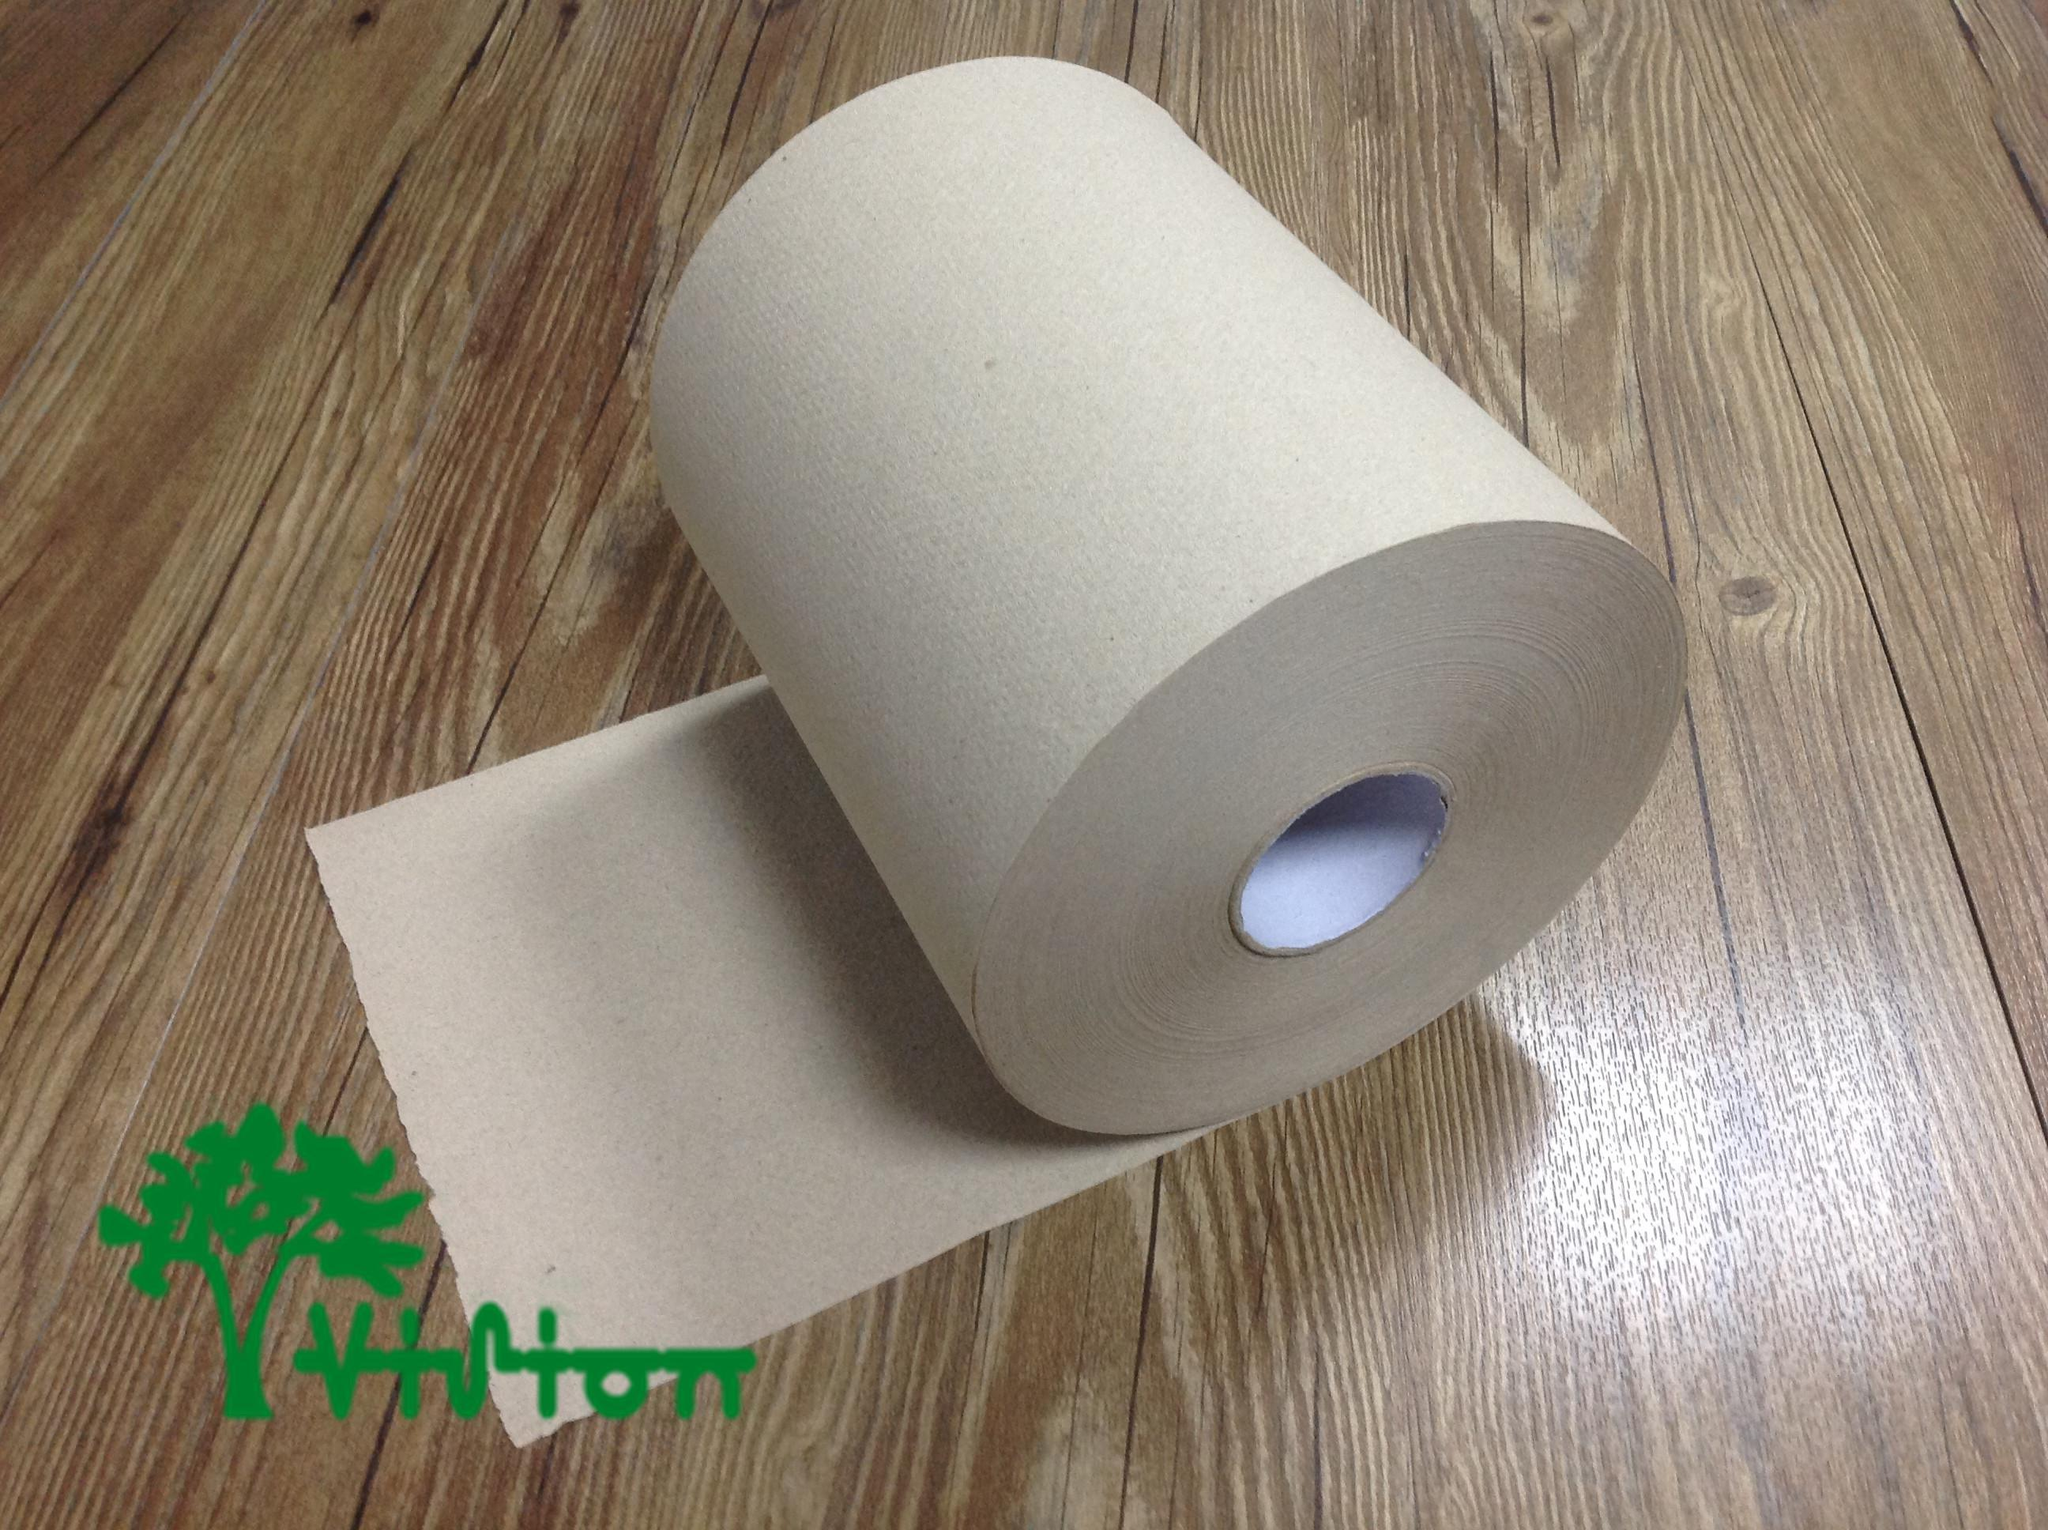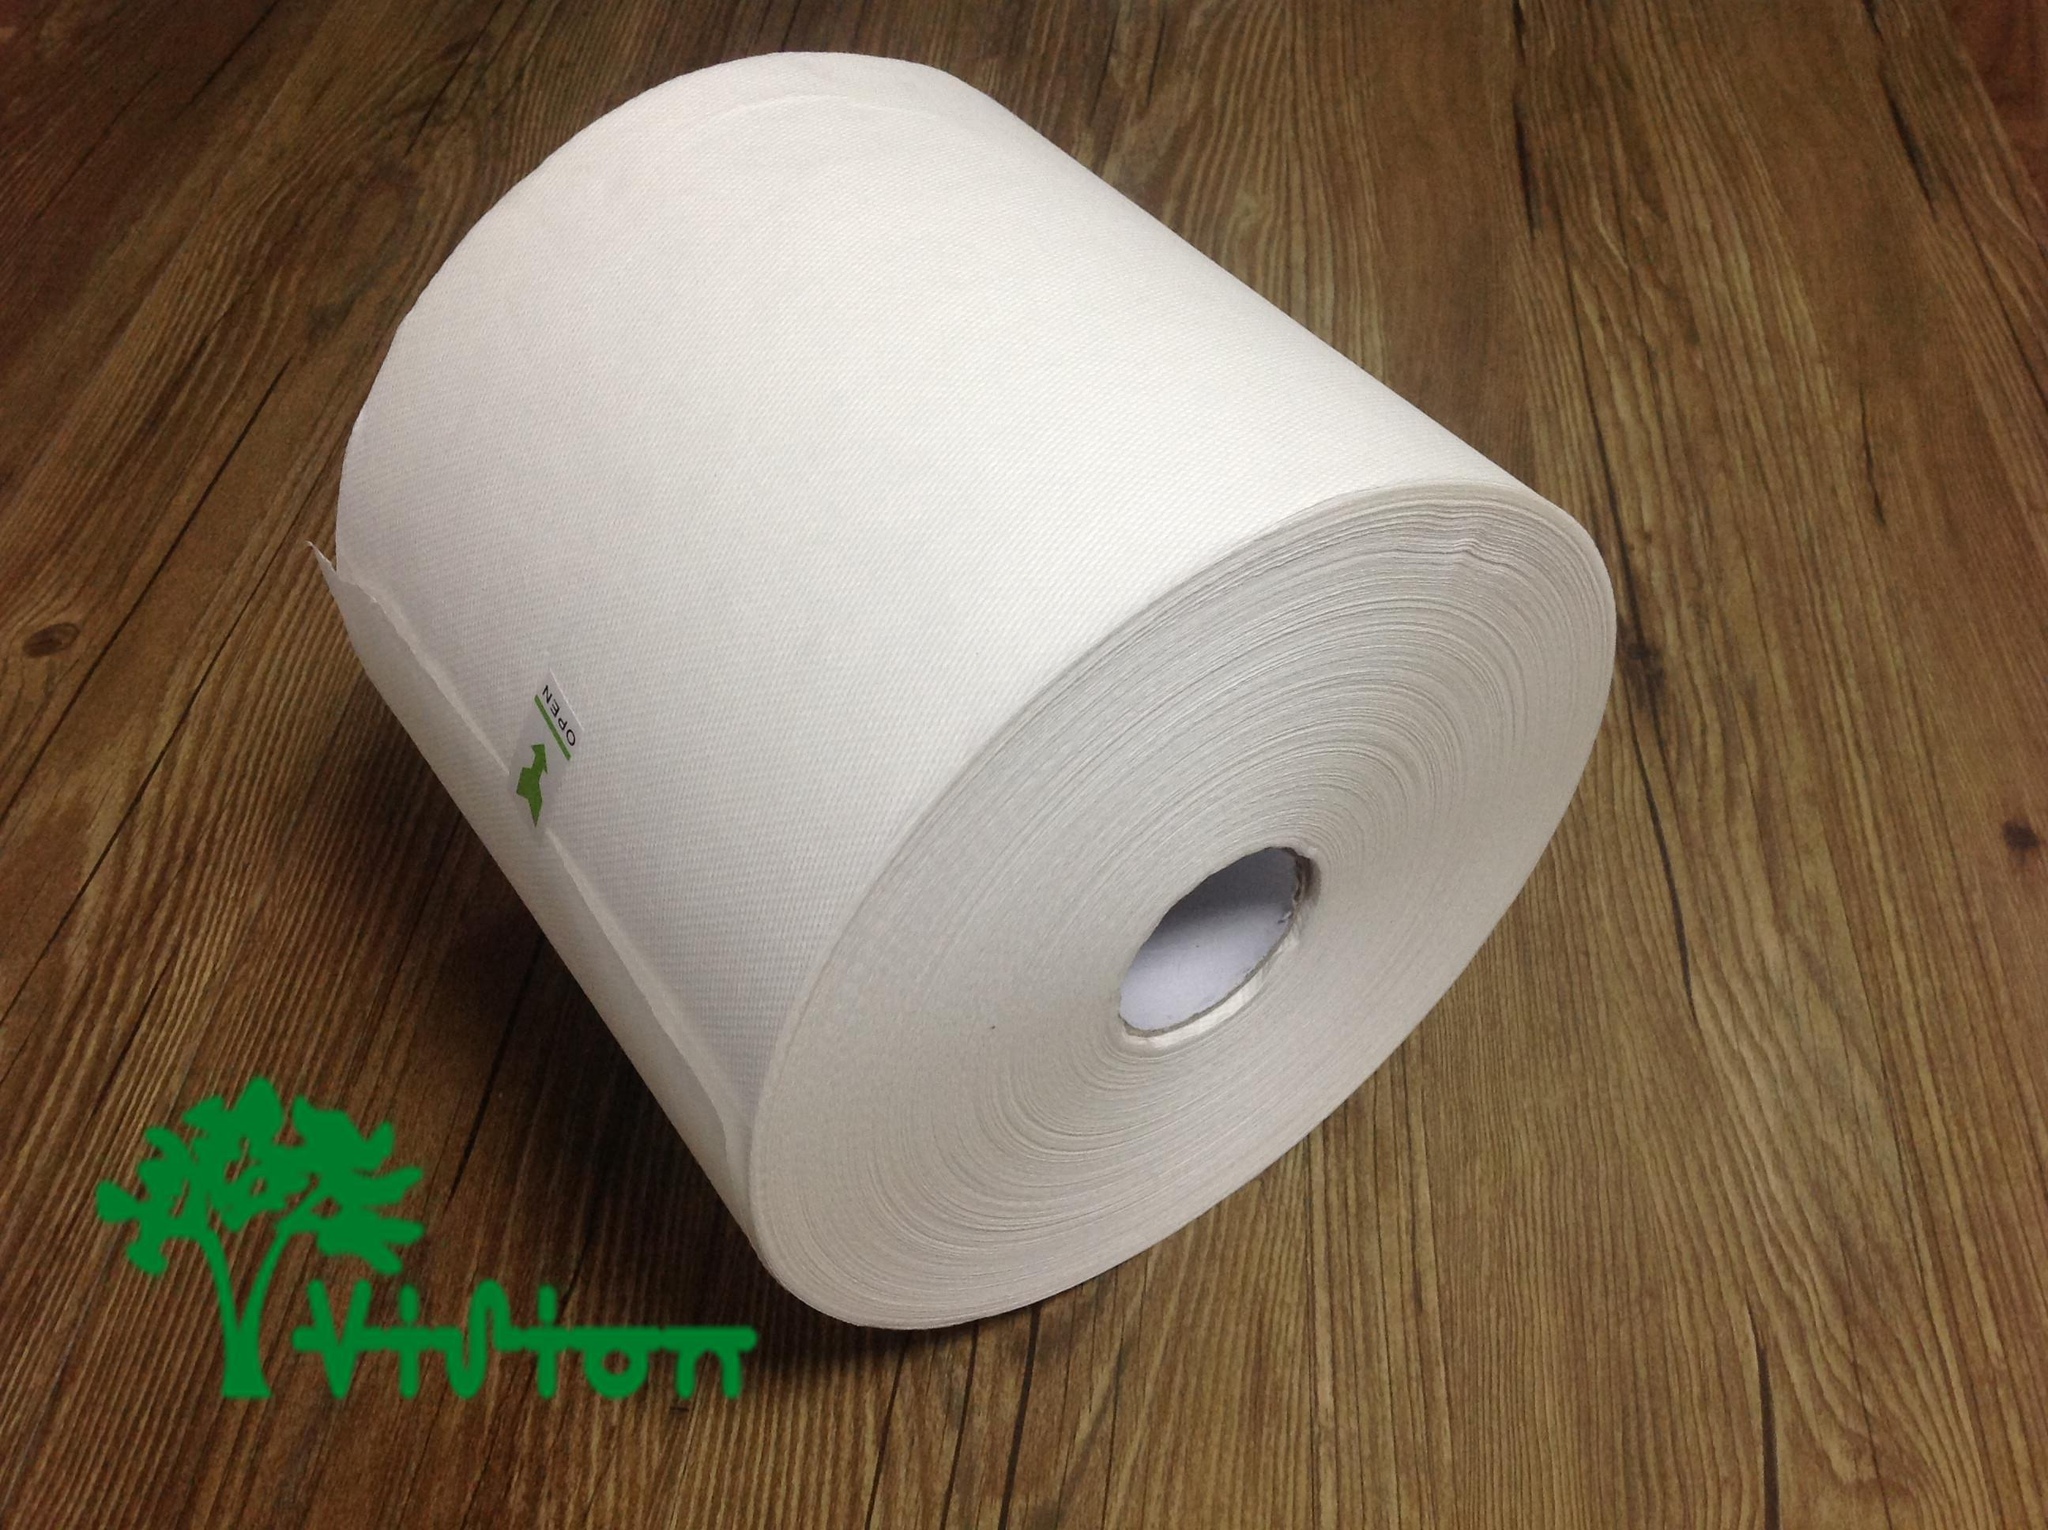The first image is the image on the left, the second image is the image on the right. For the images shown, is this caption "There are two rolls lying on a wooden surface." true? Answer yes or no. Yes. 